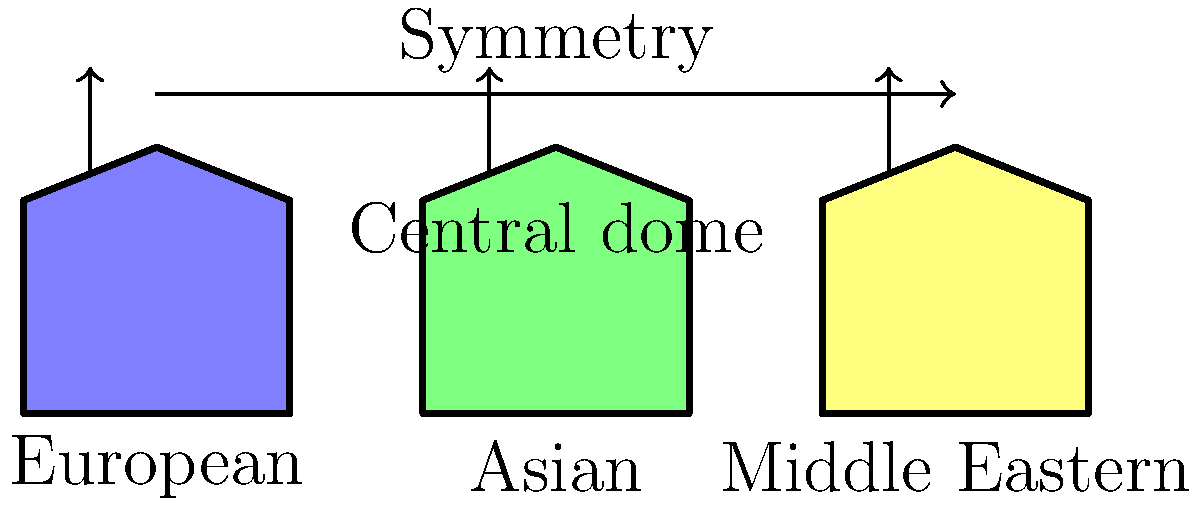Based on your research into royal architecture across cultures, which common feature is highlighted in this diagram as a unifying element in palace design, and how might this reflect the psychological profiles of royals you've studied? 1. The diagram shows three simplified palace structures representing European, Asian, and Middle Eastern royal architecture.

2. Two key features are highlighted:
   a) Symmetry: indicated by the horizontal arrow connecting all three structures
   b) Central dome: shown by vertical arrows pointing to the apex of each structure

3. Symmetry is the most prominent feature highlighted, spanning across all three cultural representations.

4. From a psychological perspective, symmetry in royal architecture can be interpreted as:
   - A reflection of the desire for order and balance in governance
   - A symbol of perfection and divine right to rule
   - A manifestation of the need for control and predictability

5. The central dome, while also common, is secondary in the diagram. It can be psychologically interpreted as:
   - A representation of centralized power
   - An aspiration towards the heavens, reinforcing divine authority
   - A symbol of the all-seeing nature of royal rule

6. The consistency of these features across cultures suggests universal psychological traits among royals, such as:
   - A need for visual representation of power and authority
   - A desire to create a sense of awe and reverence
   - An attempt to legitimize rule through architectural grandeur

7. The symmetry, being the most emphasized feature, aligns with the psychological profile of royals as individuals striving for balance, perfection, and absolute control in their realms.
Answer: Symmetry, reflecting royals' desire for order, balance, and control in governance. 